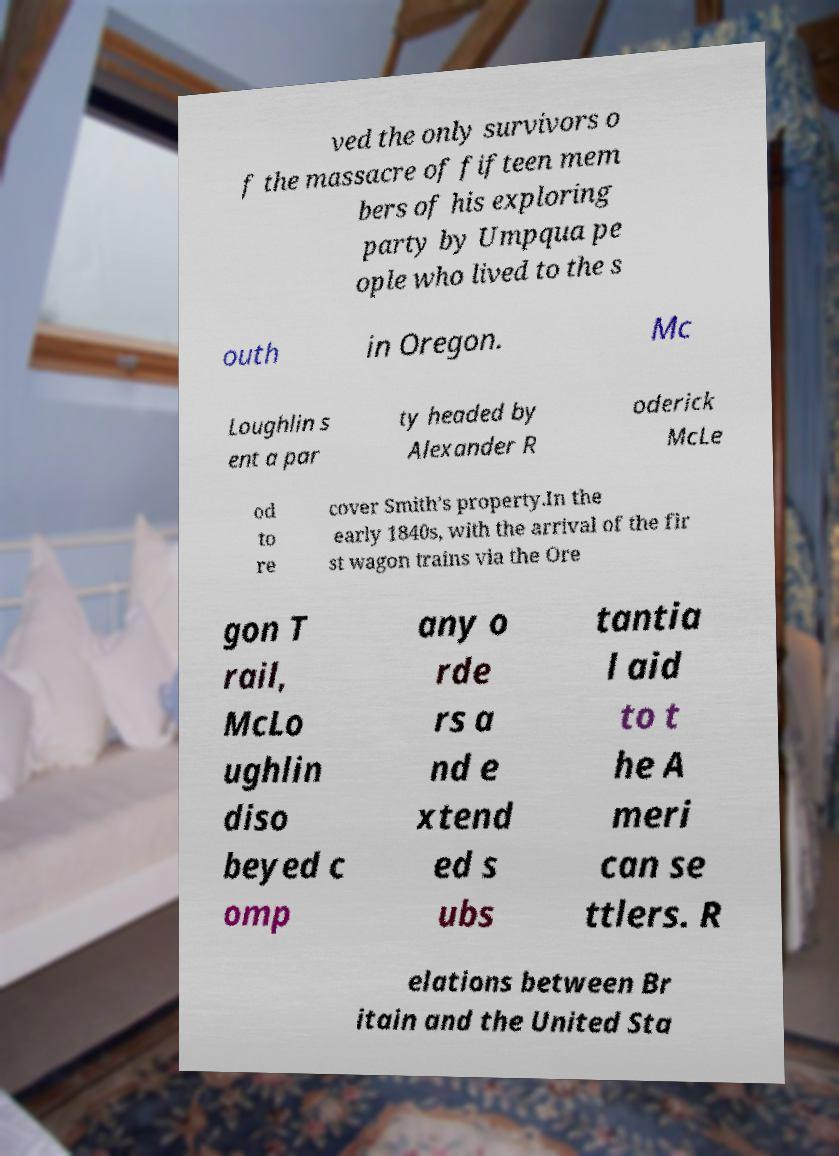I need the written content from this picture converted into text. Can you do that? ved the only survivors o f the massacre of fifteen mem bers of his exploring party by Umpqua pe ople who lived to the s outh in Oregon. Mc Loughlin s ent a par ty headed by Alexander R oderick McLe od to re cover Smith’s property.In the early 1840s, with the arrival of the fir st wagon trains via the Ore gon T rail, McLo ughlin diso beyed c omp any o rde rs a nd e xtend ed s ubs tantia l aid to t he A meri can se ttlers. R elations between Br itain and the United Sta 